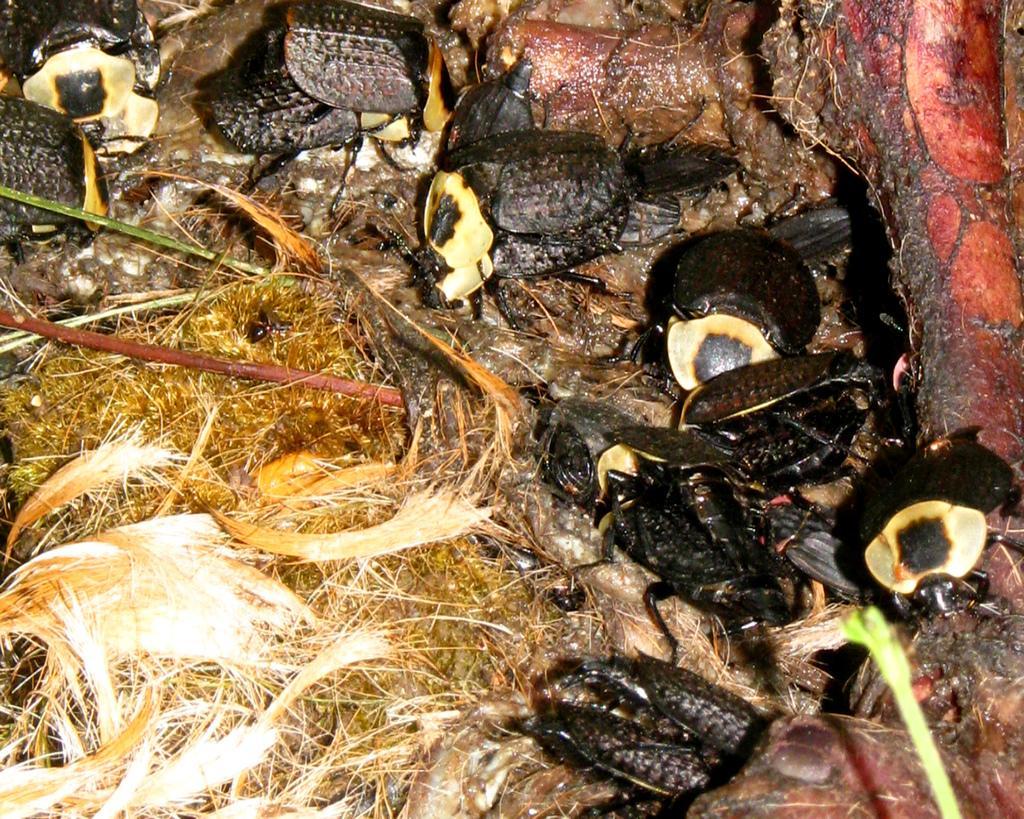What type of creatures are present in the image? There are black color insects in the image. What is the surface on which the insects are located? The insects are on a grass-like surface. What is the rate at which the robin is paddling the boat in the image? There is no robin or boat present in the image; it features black color insects on a grass-like surface. 